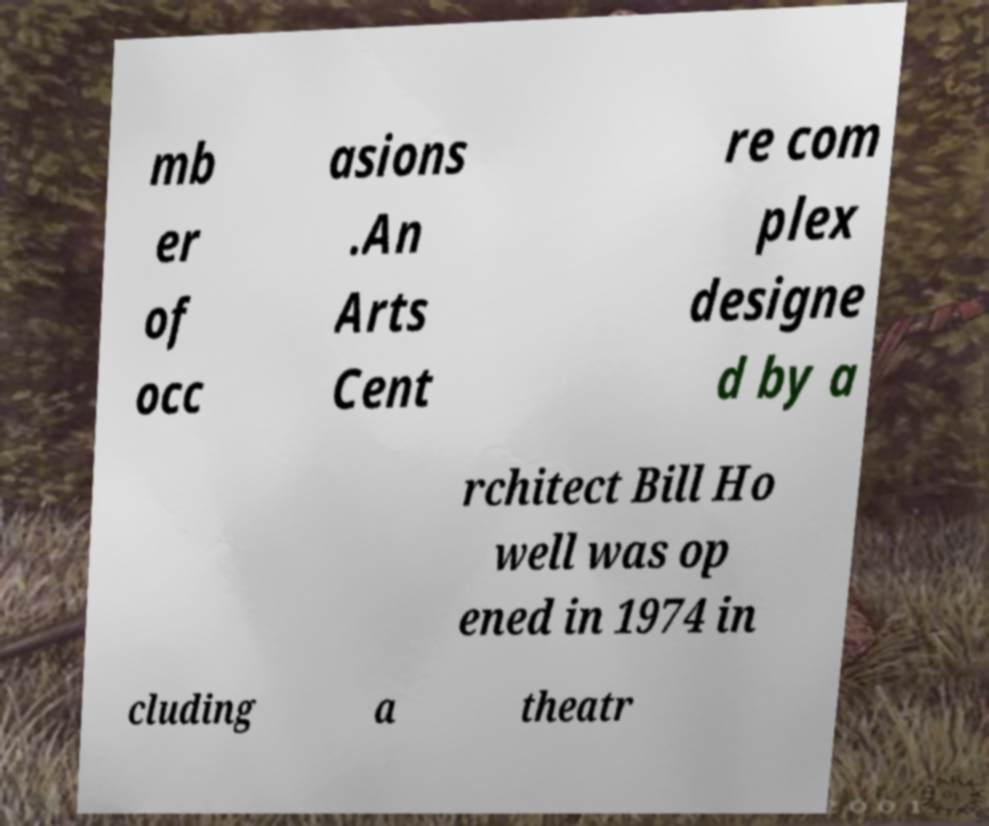I need the written content from this picture converted into text. Can you do that? mb er of occ asions .An Arts Cent re com plex designe d by a rchitect Bill Ho well was op ened in 1974 in cluding a theatr 